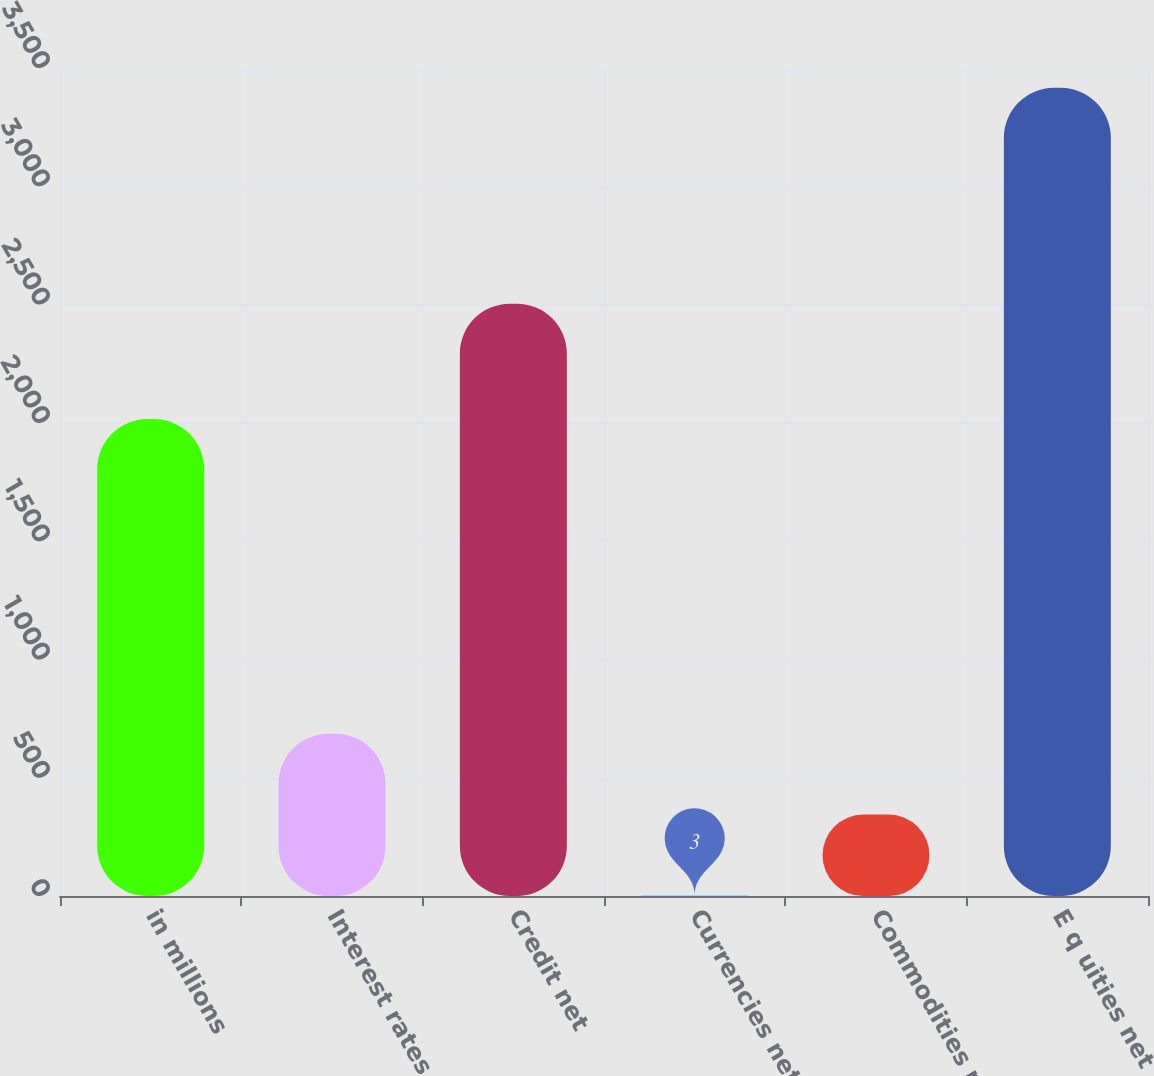Convert chart to OTSL. <chart><loc_0><loc_0><loc_500><loc_500><bar_chart><fcel>in millions<fcel>Interest rates net<fcel>Credit net<fcel>Currencies net<fcel>Commodities net<fcel>E q uities net<nl><fcel>2016<fcel>685.6<fcel>2504<fcel>3<fcel>344.3<fcel>3416<nl></chart> 